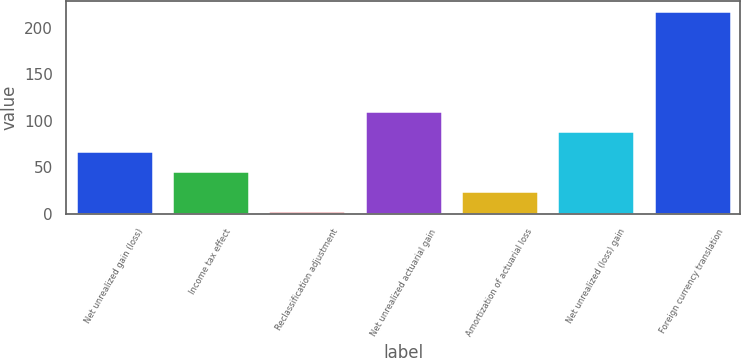<chart> <loc_0><loc_0><loc_500><loc_500><bar_chart><fcel>Net unrealized gain (loss)<fcel>Income tax effect<fcel>Reclassification adjustment<fcel>Net unrealized actuarial gain<fcel>Amortization of actuarial loss<fcel>Net unrealized (loss) gain<fcel>Foreign currency translation<nl><fcel>67.5<fcel>46<fcel>3<fcel>110.5<fcel>24.5<fcel>89<fcel>218<nl></chart> 